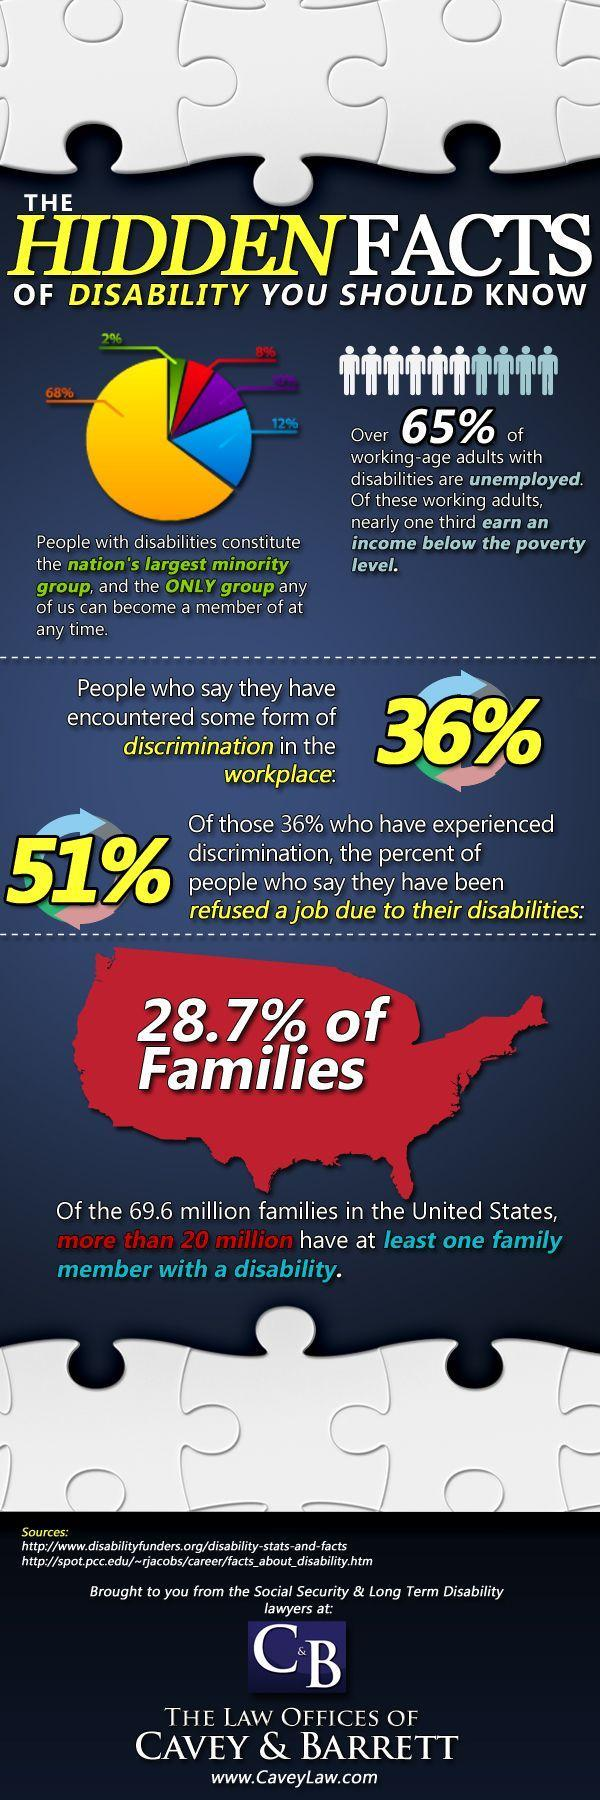What percent of people do not encountered any kind of discrimination in the workplace in U.S.?
Answer the question with a short phrase. 64% What type of people constitute the U.S. nation's largest minority group? People with disabilities What percent of people in U.S have been refused a job due to their disabilities? 51% 